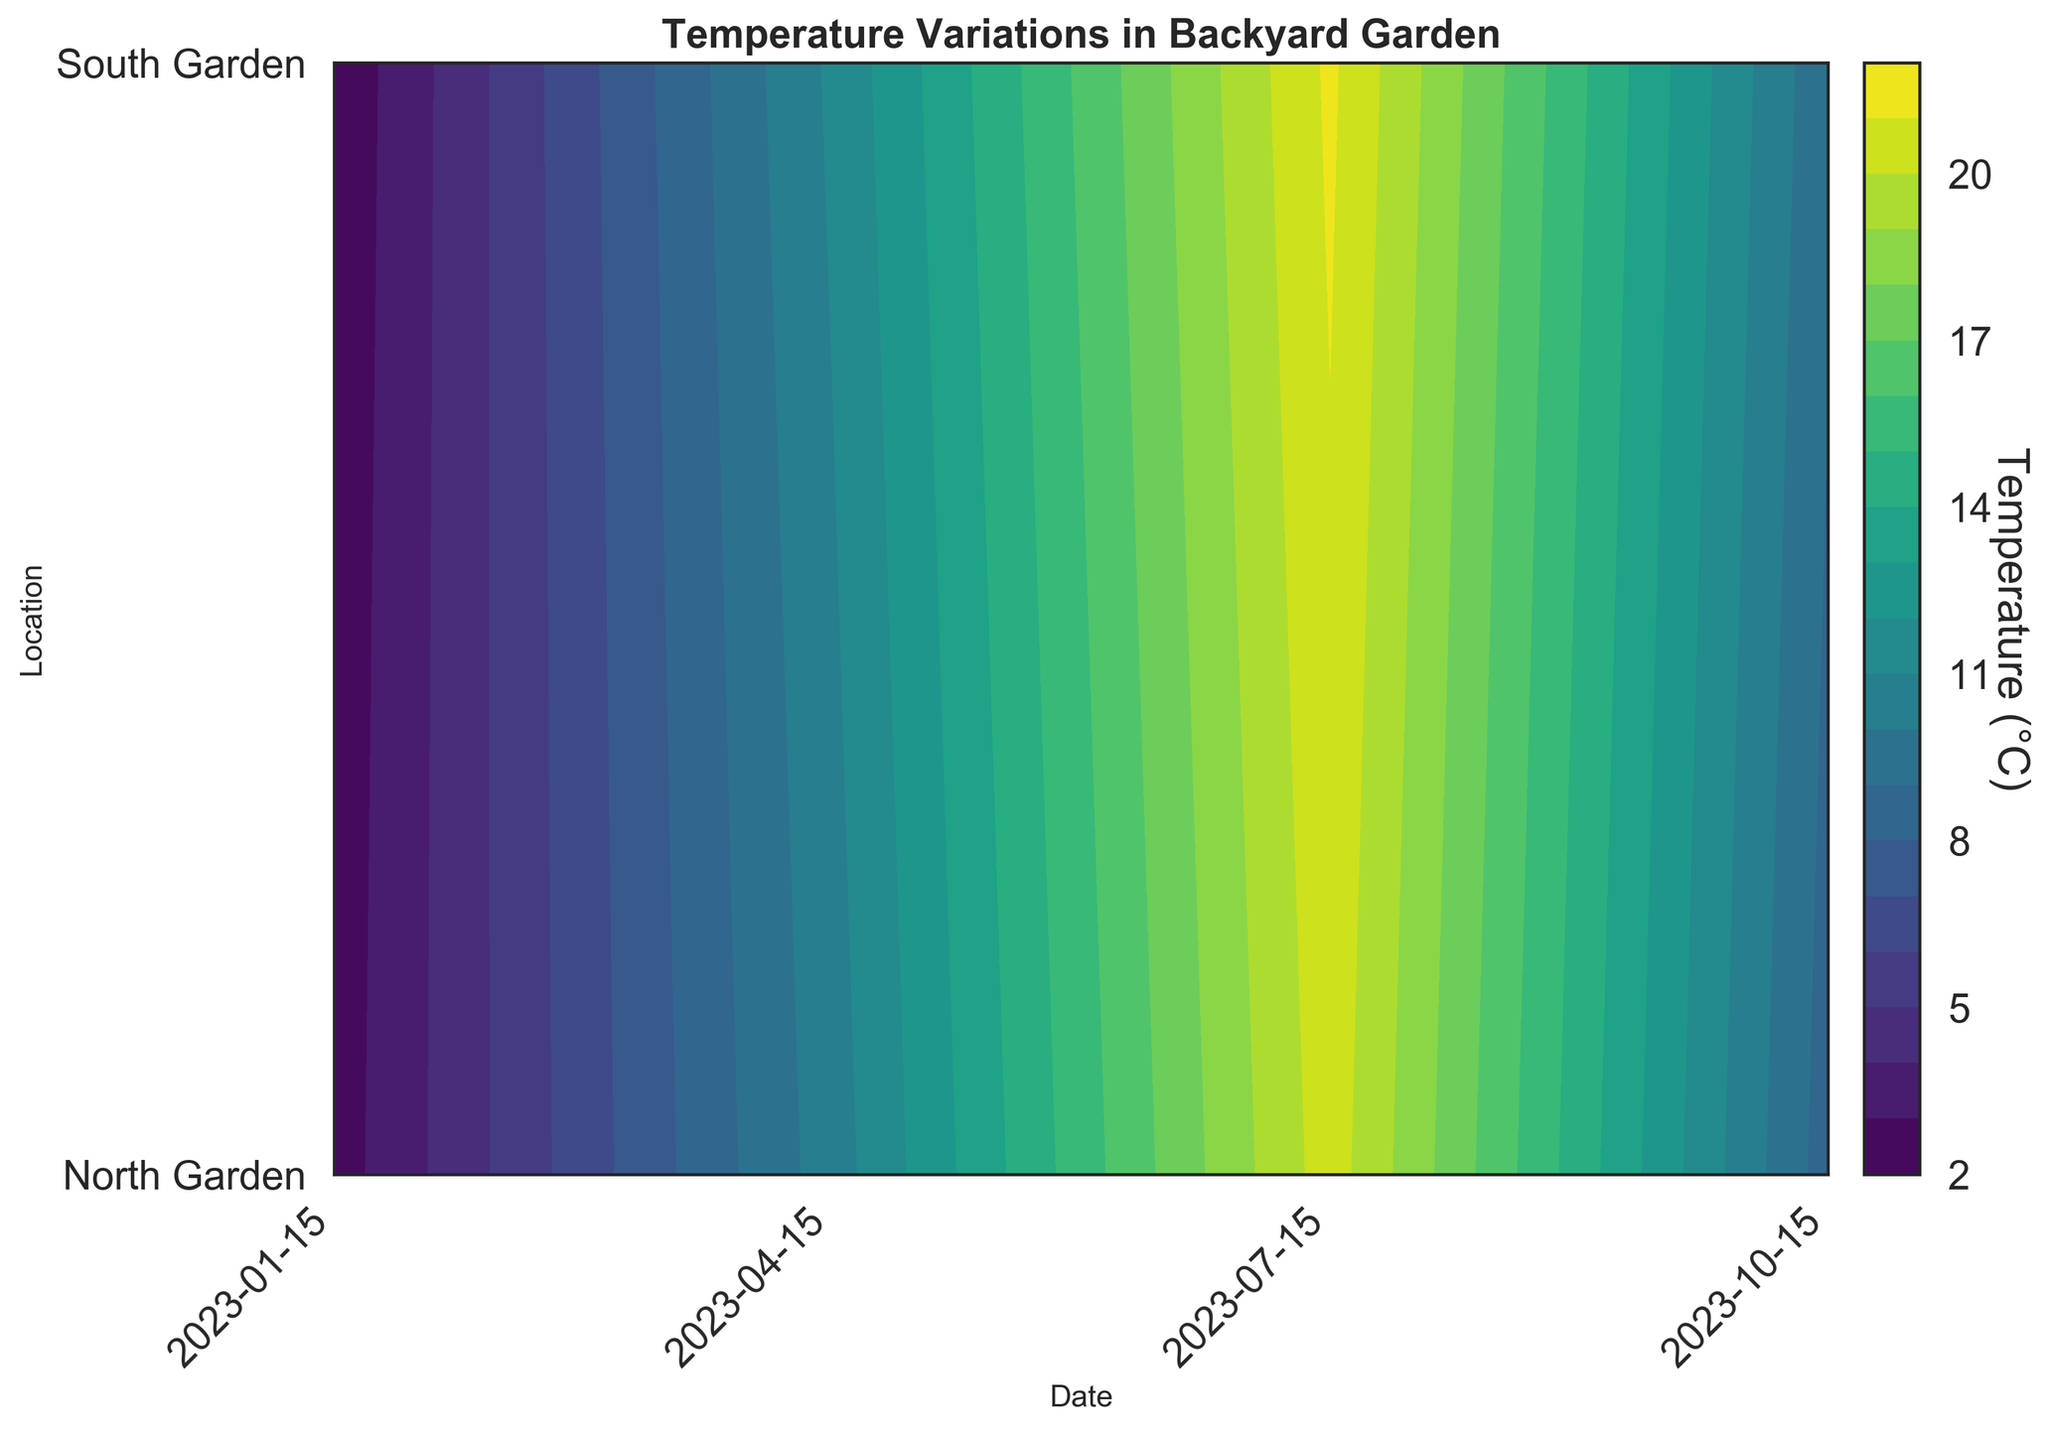What is the title of the figure? The title is usually placed at the top of the figure and is meant to provide an overall description of what the figure is about.
Answer: Temperature Variations in Backyard Garden What does the color represent in this contour plot? The color in a contour plot is generally used to represent different levels of the variable being measured. Here, the color represents the temperature in Celsius.
Answer: Temperature (°C) What are the labels of the x-axis and y-axis? The x-axis label is positioned at the bottom of the figure, representing a variable, and the y-axis label is on the side, representing another variable. The x-axis is labeled "Date," and the y-axis is labeled "Location."
Answer: Date, Location Which time period on the x-axis shows the highest temperatures? By observing the contour plot, we look at the color gradients that indicate higher temperatures across different time periods on the x-axis, which shows the dates. The warmest period appears to be around mid-July.
Answer: Mid-July What is the temperature range in the North Garden during April? To determine this, focus on the specific area of the contour plot corresponding to the North Garden row and the dates in April. Identify the contour lines and the color gradients representing different temperatures. The temperatures range around 10.5°C to 16.2°C according to the colors and levels.
Answer: 10.5°C to 16.2°C What is the difference in temperature between the North and South Garden on July 15 at 12:00? Identify the temperature values in both the North and South Garden for the specified date and time from their color intensities. The North Garden shows around 27.2°C, while the South Garden shows around 28.8°C, resulting in a difference of 1.6°C.
Answer: 1.6°C Which season shows the greatest difference in temperature between the North and South Gardens? The greatest difference is found by comparing the temperatures in different seasons for both gardens and selecting the maximum difference. The largest difference appears in July, where temperatures differ by about 1.6°C.
Answer: Summer (July) How does the temperature gradient change from morning to afternoon in October in the North Garden? Observe the shifts in color gradients from 08:00 to 16:00 for October in the North Garden region of the plot. In the morning, the color is lighter (~8.5°C) and becomes darker toward the afternoon, indicating an increase in temperature (~15.2°C).
Answer: It increases from ~8.5°C to ~15.2°C Is there a significant overlap of temperature ranges between the North Garden and South Garden across the months? Check the contour levels and color overlaps for both locations across different months on the y-axis. Noticeable overlaps in color indicate similar temperature ranges. There are significant overlaps, considering the similar gradations seen in both gardens each month.
Answer: Yes, there is significant overlap 